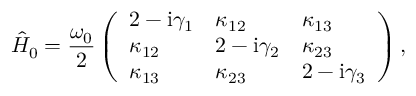<formula> <loc_0><loc_0><loc_500><loc_500>\hat { H } _ { 0 } = \frac { \omega _ { 0 } } { 2 } \left ( \begin{array} { l l l } { 2 - i \gamma _ { 1 } } & { \kappa _ { 1 2 } } & { \kappa _ { 1 3 } } \\ { \kappa _ { 1 2 } } & { 2 - i \gamma _ { 2 } } & { \kappa _ { 2 3 } } \\ { \kappa _ { 1 3 } } & { \kappa _ { 2 3 } } & { 2 - i \gamma _ { 3 } } \end{array} \right ) ,</formula> 